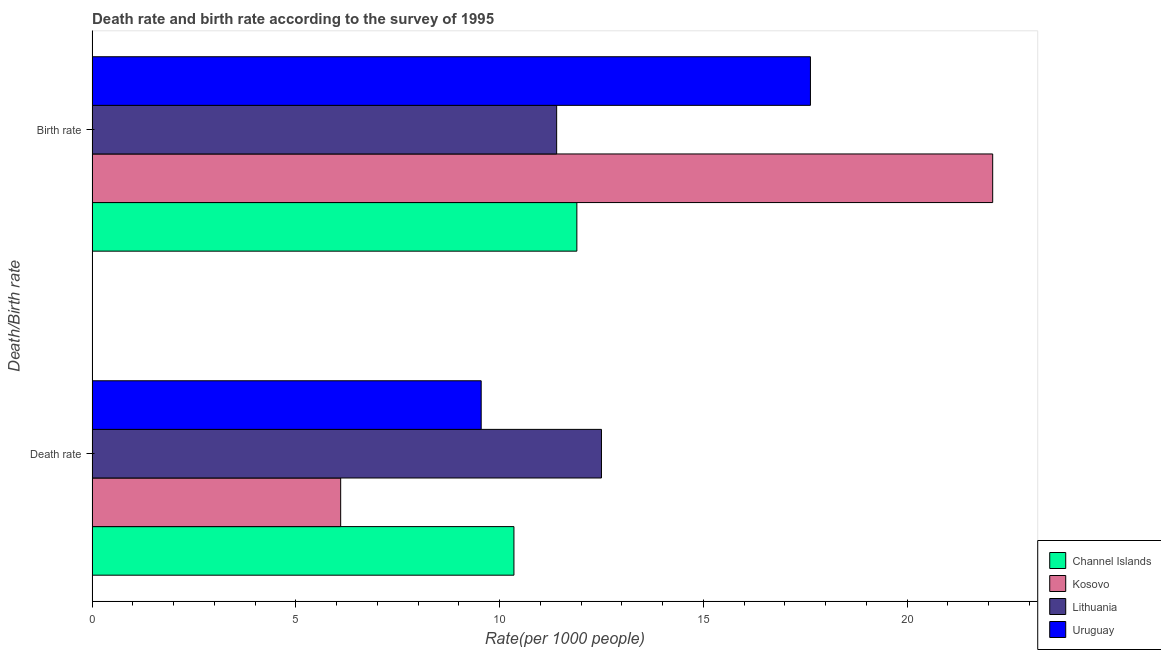How many different coloured bars are there?
Your answer should be compact. 4. How many groups of bars are there?
Offer a terse response. 2. Are the number of bars per tick equal to the number of legend labels?
Make the answer very short. Yes. What is the label of the 1st group of bars from the top?
Keep it short and to the point. Birth rate. What is the birth rate in Uruguay?
Your answer should be very brief. 17.63. Across all countries, what is the maximum birth rate?
Offer a terse response. 22.1. Across all countries, what is the minimum birth rate?
Offer a very short reply. 11.4. In which country was the death rate maximum?
Give a very brief answer. Lithuania. In which country was the death rate minimum?
Ensure brevity in your answer.  Kosovo. What is the total birth rate in the graph?
Make the answer very short. 63.02. What is the difference between the birth rate in Lithuania and that in Channel Islands?
Give a very brief answer. -0.5. What is the difference between the death rate in Kosovo and the birth rate in Lithuania?
Your answer should be very brief. -5.3. What is the average birth rate per country?
Offer a very short reply. 15.76. What is the difference between the death rate and birth rate in Channel Islands?
Keep it short and to the point. -1.54. In how many countries, is the birth rate greater than 13 ?
Offer a terse response. 2. What is the ratio of the death rate in Lithuania to that in Uruguay?
Provide a short and direct response. 1.31. Is the death rate in Kosovo less than that in Uruguay?
Your answer should be compact. Yes. What does the 2nd bar from the top in Birth rate represents?
Offer a very short reply. Lithuania. What does the 3rd bar from the bottom in Death rate represents?
Your response must be concise. Lithuania. Does the graph contain grids?
Your answer should be compact. No. How are the legend labels stacked?
Keep it short and to the point. Vertical. What is the title of the graph?
Your response must be concise. Death rate and birth rate according to the survey of 1995. What is the label or title of the X-axis?
Give a very brief answer. Rate(per 1000 people). What is the label or title of the Y-axis?
Make the answer very short. Death/Birth rate. What is the Rate(per 1000 people) of Channel Islands in Death rate?
Provide a succinct answer. 10.35. What is the Rate(per 1000 people) in Uruguay in Death rate?
Offer a very short reply. 9.55. What is the Rate(per 1000 people) in Channel Islands in Birth rate?
Offer a very short reply. 11.9. What is the Rate(per 1000 people) of Kosovo in Birth rate?
Provide a succinct answer. 22.1. What is the Rate(per 1000 people) in Uruguay in Birth rate?
Provide a succinct answer. 17.63. Across all Death/Birth rate, what is the maximum Rate(per 1000 people) in Channel Islands?
Offer a very short reply. 11.9. Across all Death/Birth rate, what is the maximum Rate(per 1000 people) in Kosovo?
Your response must be concise. 22.1. Across all Death/Birth rate, what is the maximum Rate(per 1000 people) of Uruguay?
Keep it short and to the point. 17.63. Across all Death/Birth rate, what is the minimum Rate(per 1000 people) in Channel Islands?
Offer a very short reply. 10.35. Across all Death/Birth rate, what is the minimum Rate(per 1000 people) in Kosovo?
Your response must be concise. 6.1. Across all Death/Birth rate, what is the minimum Rate(per 1000 people) in Lithuania?
Your response must be concise. 11.4. Across all Death/Birth rate, what is the minimum Rate(per 1000 people) in Uruguay?
Give a very brief answer. 9.55. What is the total Rate(per 1000 people) in Channel Islands in the graph?
Your response must be concise. 22.25. What is the total Rate(per 1000 people) in Kosovo in the graph?
Make the answer very short. 28.2. What is the total Rate(per 1000 people) of Lithuania in the graph?
Your answer should be compact. 23.9. What is the total Rate(per 1000 people) in Uruguay in the graph?
Offer a very short reply. 27.18. What is the difference between the Rate(per 1000 people) in Channel Islands in Death rate and that in Birth rate?
Offer a very short reply. -1.54. What is the difference between the Rate(per 1000 people) of Kosovo in Death rate and that in Birth rate?
Your answer should be very brief. -16. What is the difference between the Rate(per 1000 people) of Uruguay in Death rate and that in Birth rate?
Keep it short and to the point. -8.08. What is the difference between the Rate(per 1000 people) of Channel Islands in Death rate and the Rate(per 1000 people) of Kosovo in Birth rate?
Ensure brevity in your answer.  -11.75. What is the difference between the Rate(per 1000 people) of Channel Islands in Death rate and the Rate(per 1000 people) of Lithuania in Birth rate?
Offer a very short reply. -1.05. What is the difference between the Rate(per 1000 people) of Channel Islands in Death rate and the Rate(per 1000 people) of Uruguay in Birth rate?
Your answer should be very brief. -7.28. What is the difference between the Rate(per 1000 people) in Kosovo in Death rate and the Rate(per 1000 people) in Uruguay in Birth rate?
Give a very brief answer. -11.53. What is the difference between the Rate(per 1000 people) in Lithuania in Death rate and the Rate(per 1000 people) in Uruguay in Birth rate?
Offer a very short reply. -5.13. What is the average Rate(per 1000 people) of Channel Islands per Death/Birth rate?
Provide a succinct answer. 11.12. What is the average Rate(per 1000 people) of Kosovo per Death/Birth rate?
Your answer should be very brief. 14.1. What is the average Rate(per 1000 people) in Lithuania per Death/Birth rate?
Your response must be concise. 11.95. What is the average Rate(per 1000 people) in Uruguay per Death/Birth rate?
Provide a succinct answer. 13.59. What is the difference between the Rate(per 1000 people) of Channel Islands and Rate(per 1000 people) of Kosovo in Death rate?
Ensure brevity in your answer.  4.25. What is the difference between the Rate(per 1000 people) in Channel Islands and Rate(per 1000 people) in Lithuania in Death rate?
Your answer should be very brief. -2.15. What is the difference between the Rate(per 1000 people) in Channel Islands and Rate(per 1000 people) in Uruguay in Death rate?
Keep it short and to the point. 0.8. What is the difference between the Rate(per 1000 people) in Kosovo and Rate(per 1000 people) in Uruguay in Death rate?
Ensure brevity in your answer.  -3.45. What is the difference between the Rate(per 1000 people) of Lithuania and Rate(per 1000 people) of Uruguay in Death rate?
Keep it short and to the point. 2.95. What is the difference between the Rate(per 1000 people) in Channel Islands and Rate(per 1000 people) in Kosovo in Birth rate?
Give a very brief answer. -10.2. What is the difference between the Rate(per 1000 people) of Channel Islands and Rate(per 1000 people) of Lithuania in Birth rate?
Your answer should be very brief. 0.5. What is the difference between the Rate(per 1000 people) of Channel Islands and Rate(per 1000 people) of Uruguay in Birth rate?
Your answer should be very brief. -5.73. What is the difference between the Rate(per 1000 people) in Kosovo and Rate(per 1000 people) in Uruguay in Birth rate?
Offer a very short reply. 4.47. What is the difference between the Rate(per 1000 people) in Lithuania and Rate(per 1000 people) in Uruguay in Birth rate?
Offer a terse response. -6.23. What is the ratio of the Rate(per 1000 people) in Channel Islands in Death rate to that in Birth rate?
Ensure brevity in your answer.  0.87. What is the ratio of the Rate(per 1000 people) of Kosovo in Death rate to that in Birth rate?
Your answer should be very brief. 0.28. What is the ratio of the Rate(per 1000 people) in Lithuania in Death rate to that in Birth rate?
Offer a terse response. 1.1. What is the ratio of the Rate(per 1000 people) in Uruguay in Death rate to that in Birth rate?
Your answer should be very brief. 0.54. What is the difference between the highest and the second highest Rate(per 1000 people) in Channel Islands?
Your answer should be very brief. 1.54. What is the difference between the highest and the second highest Rate(per 1000 people) in Lithuania?
Keep it short and to the point. 1.1. What is the difference between the highest and the second highest Rate(per 1000 people) in Uruguay?
Make the answer very short. 8.08. What is the difference between the highest and the lowest Rate(per 1000 people) in Channel Islands?
Offer a very short reply. 1.54. What is the difference between the highest and the lowest Rate(per 1000 people) of Kosovo?
Keep it short and to the point. 16. What is the difference between the highest and the lowest Rate(per 1000 people) in Uruguay?
Provide a succinct answer. 8.08. 